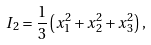Convert formula to latex. <formula><loc_0><loc_0><loc_500><loc_500>I _ { 2 } = \frac { 1 } { 3 } \left ( x _ { 1 } ^ { 2 } + x _ { 2 } ^ { 2 } + x _ { 3 } ^ { 2 } \right ) ,</formula> 